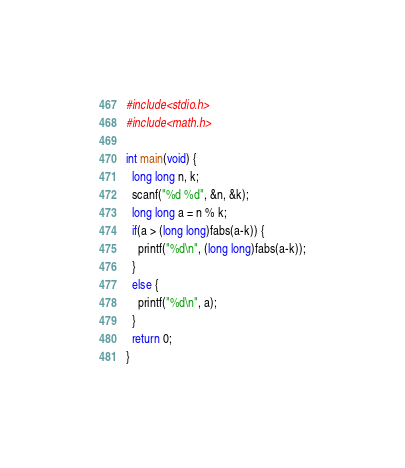Convert code to text. <code><loc_0><loc_0><loc_500><loc_500><_C_>#include<stdio.h>
#include<math.h>

int main(void) {
  long long n, k;
  scanf("%d %d", &n, &k);
  long long a = n % k;
  if(a > (long long)fabs(a-k)) {
    printf("%d\n", (long long)fabs(a-k));
  }
  else {
    printf("%d\n", a);
  }
  return 0;
}
</code> 